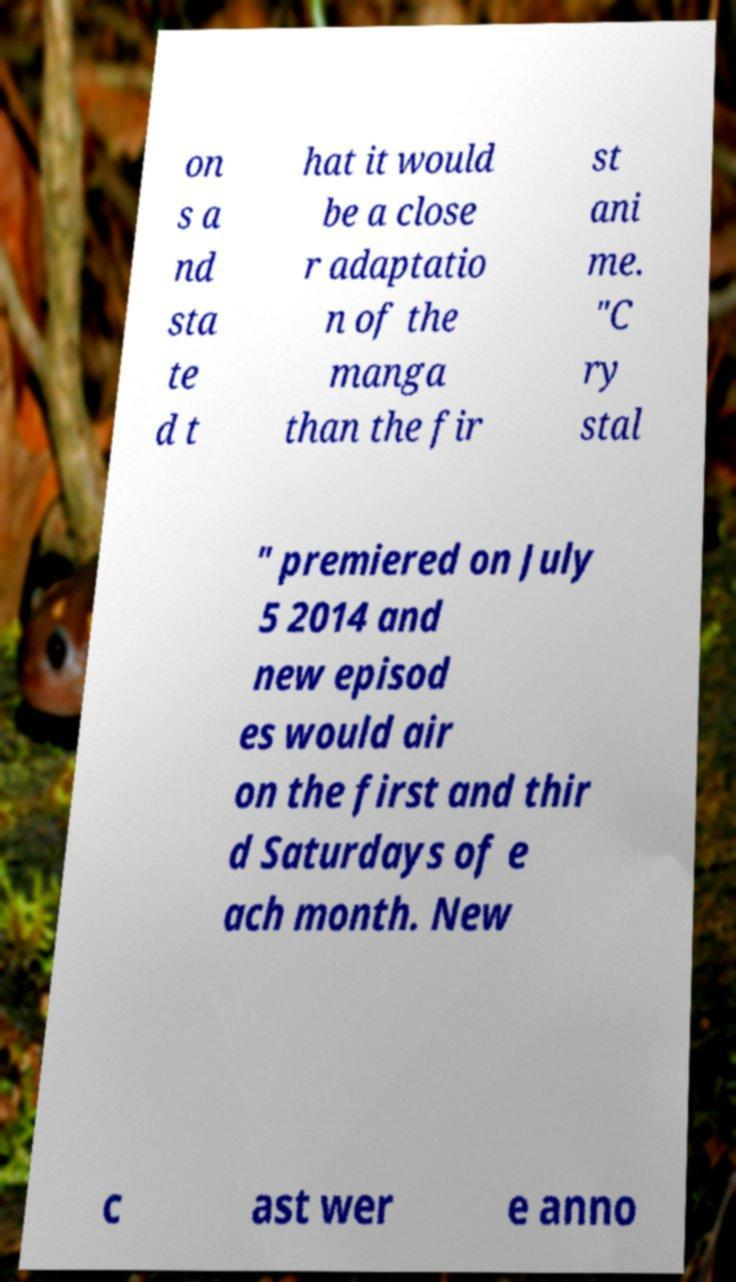There's text embedded in this image that I need extracted. Can you transcribe it verbatim? on s a nd sta te d t hat it would be a close r adaptatio n of the manga than the fir st ani me. "C ry stal " premiered on July 5 2014 and new episod es would air on the first and thir d Saturdays of e ach month. New c ast wer e anno 